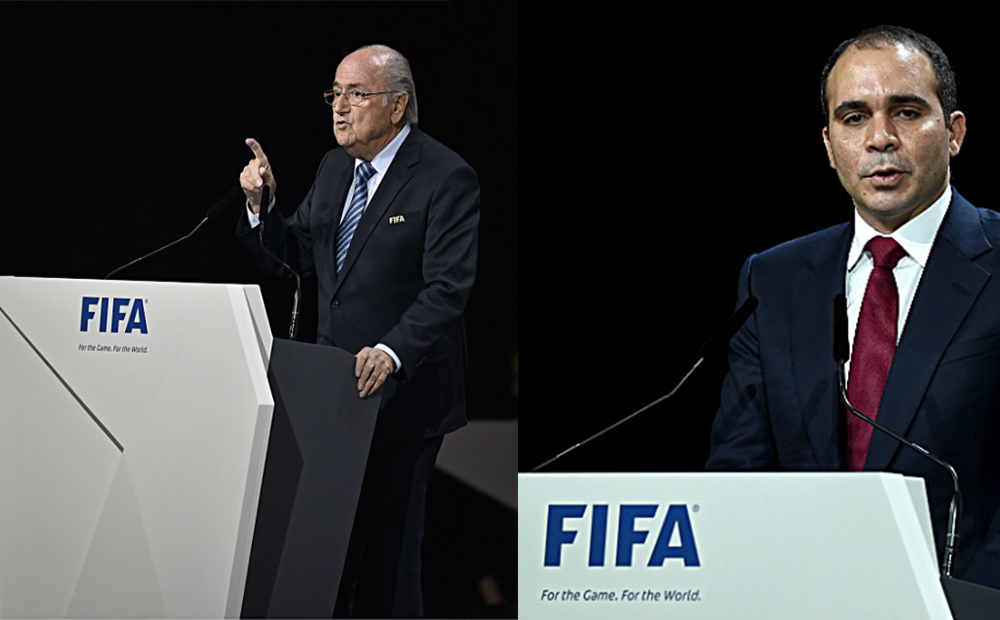Considering the context provided by the FIFA branding on the lecterns, what can be inferred about the roles or positions these two individuals might hold within the organization, and how might their attire and posture contribute to the perception of their authority and professionalism in such a setting? Given the prominence of FIFA branding on the lecterns, it's likely these individuals are senior officials, perhaps addressing an international audience at a major football event or press conference. The formal suits and ties adhere to a universal professional standard, signaling their high-ranking status within FIFA. The older individual's pointed gesture suggests an emphasis on a particular message or directive, implying leadership and experience. In contrast, the other's straight posture and earnest expression underline a sense of duty and solemnity. The contrast in their expressions may also indicate difference in their roles or the tone of their message. Additionally, the sophisticated backdrop with controlled lighting and minimalist design sets a tone of significance and professionalism. 